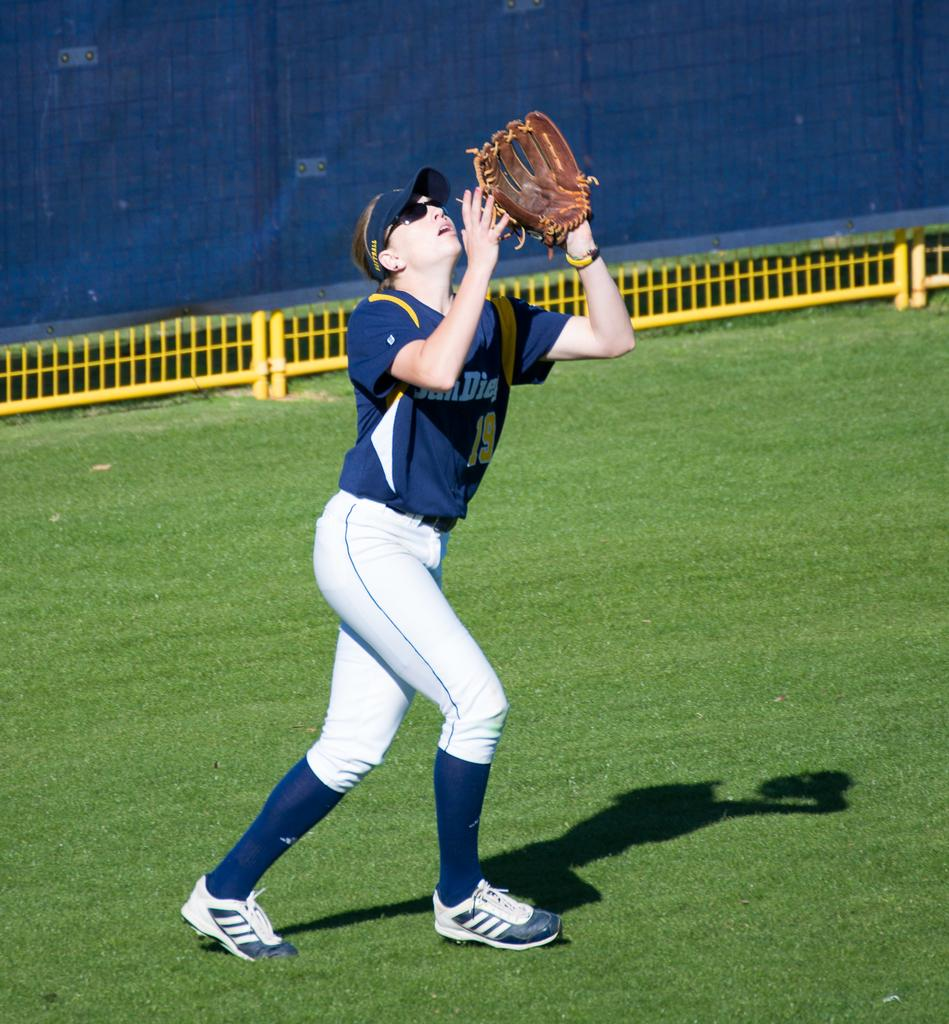<image>
Offer a succinct explanation of the picture presented. A girl wearing a San Diego uniform is holding up her glove while looking up. 